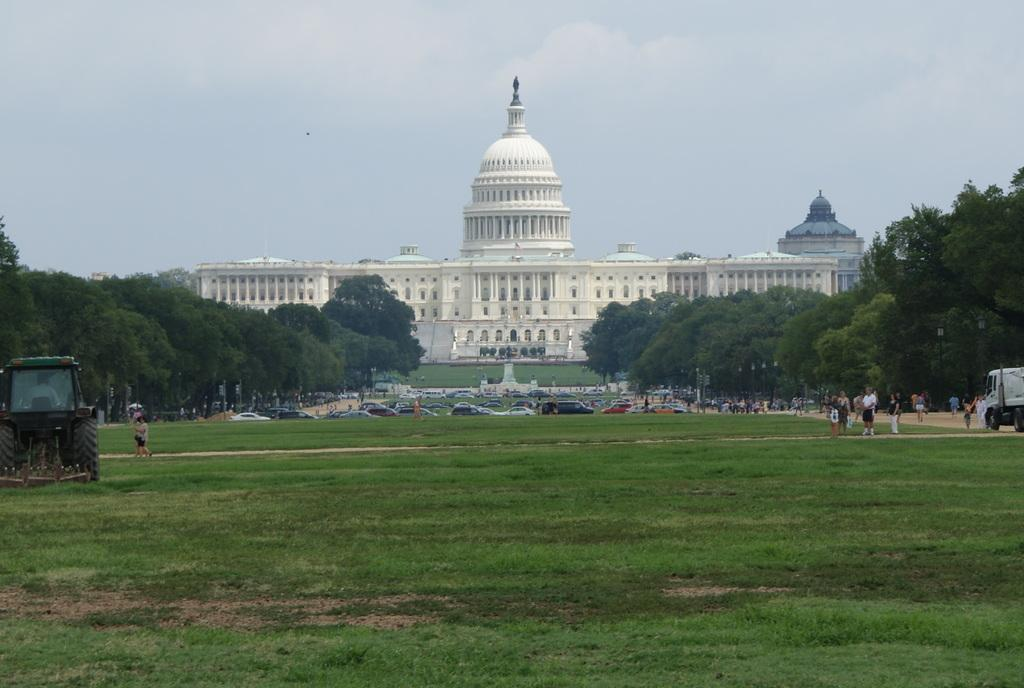What type of structure can be seen in the image? There is a building in the image. What part of the natural environment is visible in the image? The sky, trees, and grass are visible in the image. Are there any living beings present in the image? Yes, there are people in the image. What mode of transportation can be seen in the image? There is a vehicle in the image. How many apples are being held by the men in the image? There are no men or apples present in the image. What type of sugar is being used to sweeten the grass in the image? There is no sugar present in the image, and grass does not require sugar for growth or appearance. 